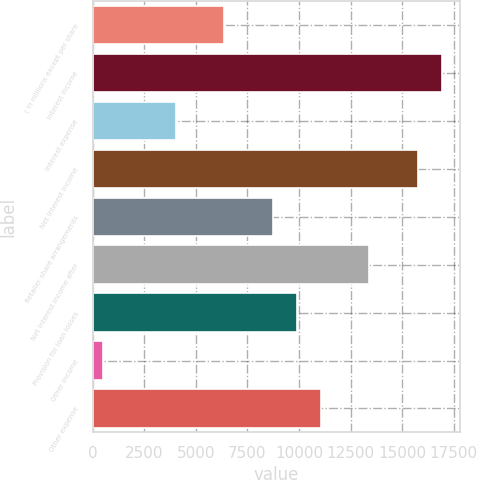Convert chart to OTSL. <chart><loc_0><loc_0><loc_500><loc_500><bar_chart><fcel>( in millions except per share<fcel>Interest income<fcel>Interest expense<fcel>Net interest income<fcel>Retailer share arrangements<fcel>Net interest income after<fcel>Provision for loan losses<fcel>Other income<fcel>Other expense<nl><fcel>6363.5<fcel>16944.8<fcel>4012.1<fcel>15769.1<fcel>8714.9<fcel>13417.7<fcel>9890.6<fcel>485<fcel>11066.3<nl></chart> 